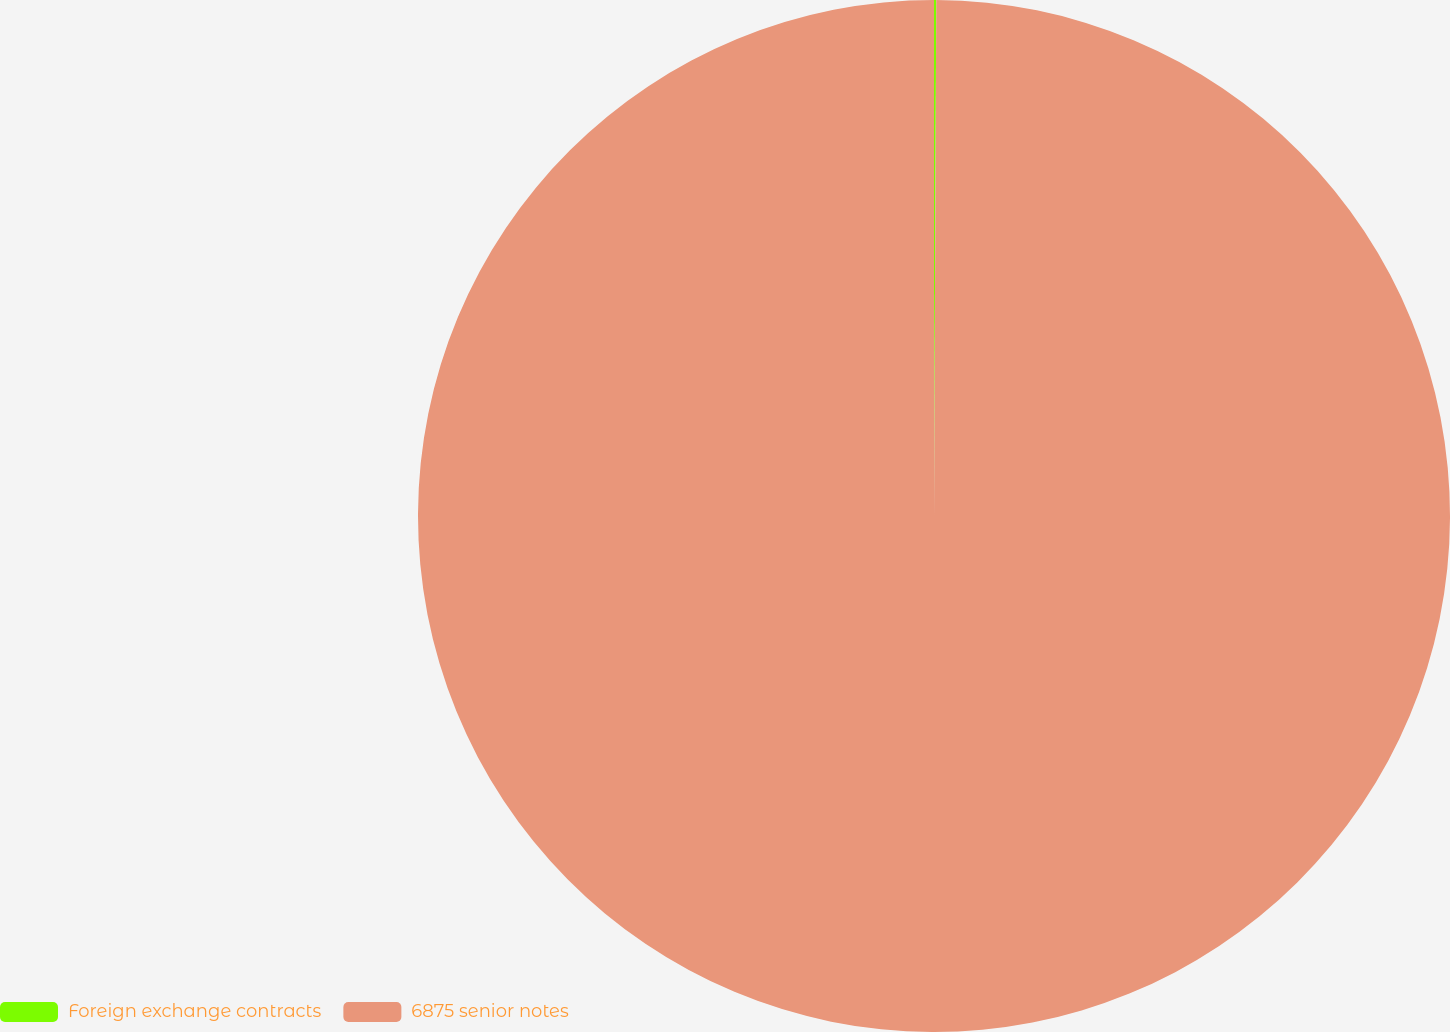<chart> <loc_0><loc_0><loc_500><loc_500><pie_chart><fcel>Foreign exchange contracts<fcel>6875 senior notes<nl><fcel>0.07%<fcel>99.93%<nl></chart> 